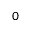Convert formula to latex. <formula><loc_0><loc_0><loc_500><loc_500>0</formula> 